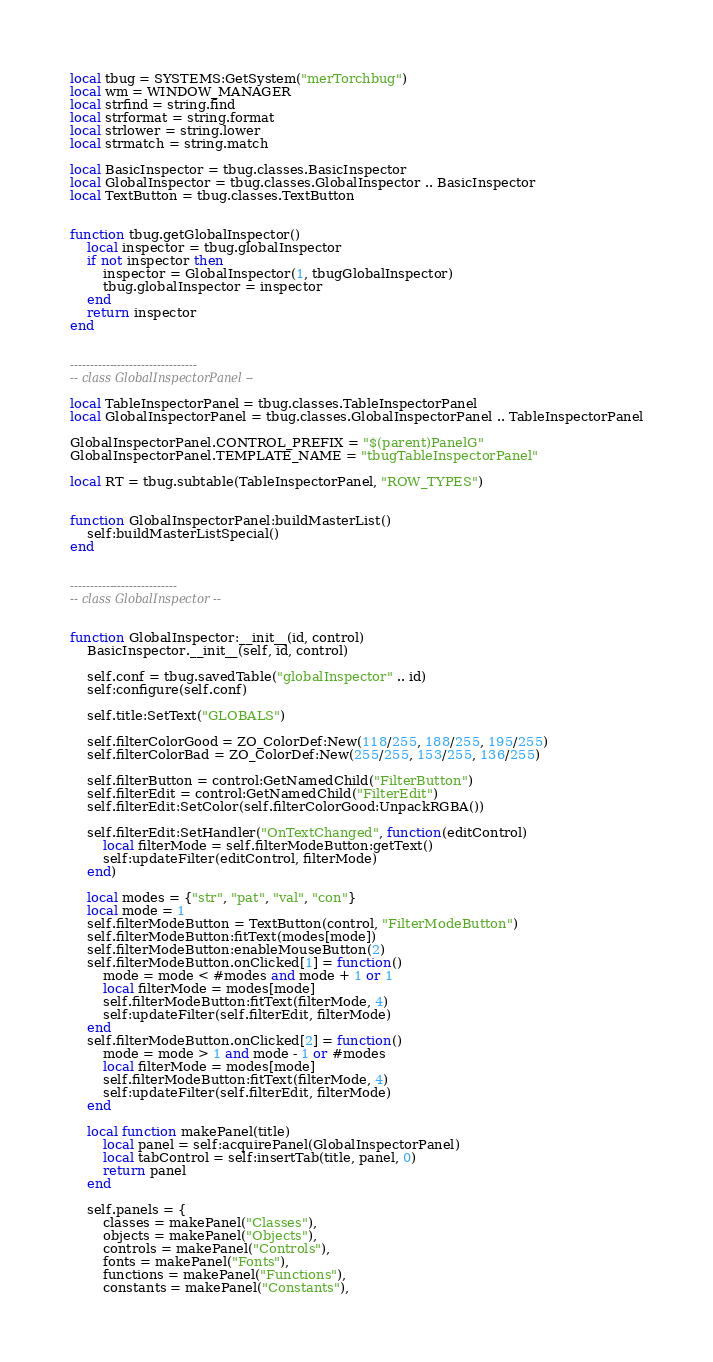<code> <loc_0><loc_0><loc_500><loc_500><_Lua_>local tbug = SYSTEMS:GetSystem("merTorchbug")
local wm = WINDOW_MANAGER
local strfind = string.find
local strformat = string.format
local strlower = string.lower
local strmatch = string.match

local BasicInspector = tbug.classes.BasicInspector
local GlobalInspector = tbug.classes.GlobalInspector .. BasicInspector
local TextButton = tbug.classes.TextButton


function tbug.getGlobalInspector()
    local inspector = tbug.globalInspector
    if not inspector then
        inspector = GlobalInspector(1, tbugGlobalInspector)
        tbug.globalInspector = inspector
    end
    return inspector
end


--------------------------------
-- class GlobalInspectorPanel --

local TableInspectorPanel = tbug.classes.TableInspectorPanel
local GlobalInspectorPanel = tbug.classes.GlobalInspectorPanel .. TableInspectorPanel

GlobalInspectorPanel.CONTROL_PREFIX = "$(parent)PanelG"
GlobalInspectorPanel.TEMPLATE_NAME = "tbugTableInspectorPanel"

local RT = tbug.subtable(TableInspectorPanel, "ROW_TYPES")


function GlobalInspectorPanel:buildMasterList()
    self:buildMasterListSpecial()
end


---------------------------
-- class GlobalInspector --


function GlobalInspector:__init__(id, control)
    BasicInspector.__init__(self, id, control)

    self.conf = tbug.savedTable("globalInspector" .. id)
    self:configure(self.conf)

    self.title:SetText("GLOBALS")

    self.filterColorGood = ZO_ColorDef:New(118/255, 188/255, 195/255)
    self.filterColorBad = ZO_ColorDef:New(255/255, 153/255, 136/255)

    self.filterButton = control:GetNamedChild("FilterButton")
    self.filterEdit = control:GetNamedChild("FilterEdit")
    self.filterEdit:SetColor(self.filterColorGood:UnpackRGBA())

    self.filterEdit:SetHandler("OnTextChanged", function(editControl)
        local filterMode = self.filterModeButton:getText()
        self:updateFilter(editControl, filterMode)
    end)

    local modes = {"str", "pat", "val", "con"}
    local mode = 1
    self.filterModeButton = TextButton(control, "FilterModeButton")
    self.filterModeButton:fitText(modes[mode])
    self.filterModeButton:enableMouseButton(2)
    self.filterModeButton.onClicked[1] = function()
        mode = mode < #modes and mode + 1 or 1
        local filterMode = modes[mode]
        self.filterModeButton:fitText(filterMode, 4)
        self:updateFilter(self.filterEdit, filterMode)
    end
    self.filterModeButton.onClicked[2] = function()
        mode = mode > 1 and mode - 1 or #modes
        local filterMode = modes[mode]
        self.filterModeButton:fitText(filterMode, 4)
        self:updateFilter(self.filterEdit, filterMode)
    end

    local function makePanel(title)
        local panel = self:acquirePanel(GlobalInspectorPanel)
        local tabControl = self:insertTab(title, panel, 0)
        return panel
    end

    self.panels = {
        classes = makePanel("Classes"),
        objects = makePanel("Objects"),
        controls = makePanel("Controls"),
        fonts = makePanel("Fonts"),
        functions = makePanel("Functions"),
        constants = makePanel("Constants"),</code> 